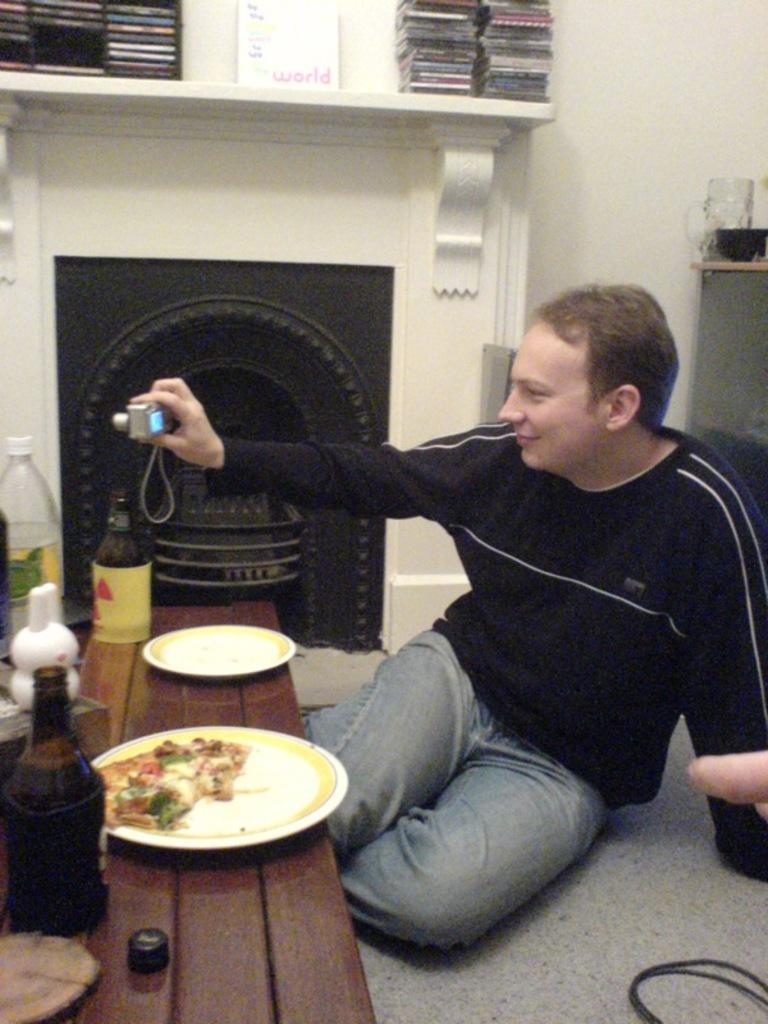Provide a one-sentence caption for the provided image. A man by a fireplace with paper that says "World" on it. 